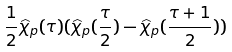Convert formula to latex. <formula><loc_0><loc_0><loc_500><loc_500>\frac { 1 } { 2 } \widehat { \chi } _ { p } ( \tau ) ( \widehat { \chi } _ { p } ( \frac { \tau } { 2 } ) - \widehat { \chi } _ { p } ( \frac { \tau + 1 } { 2 } ) )</formula> 